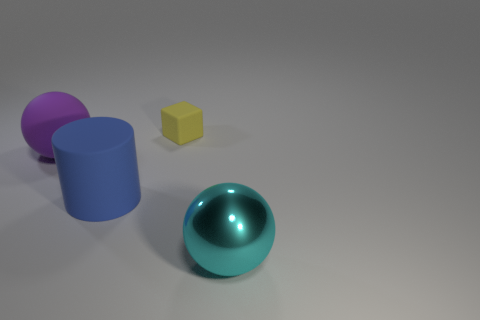Add 1 cyan spheres. How many objects exist? 5 Add 4 purple rubber spheres. How many purple rubber spheres exist? 5 Subtract 0 brown cylinders. How many objects are left? 4 Subtract all small brown cubes. Subtract all large blue rubber cylinders. How many objects are left? 3 Add 1 big blue cylinders. How many big blue cylinders are left? 2 